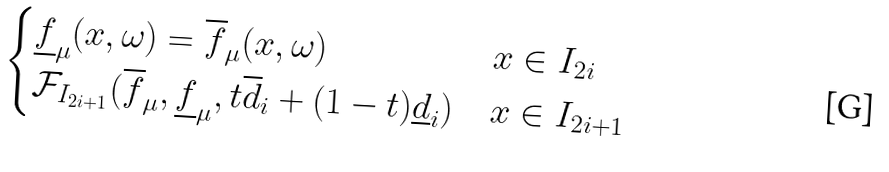<formula> <loc_0><loc_0><loc_500><loc_500>\begin{cases} \underline { f } _ { \mu } ( x , \omega ) = \overline { f } _ { \mu } ( x , \omega ) & x \in I _ { 2 i } \\ \mathcal { F } _ { I _ { 2 i + 1 } } ( \overline { f } _ { \mu } , \underline { f } _ { \mu } , t \overline { d } _ { i } + ( 1 - t ) \underline { d } _ { i } ) & x \in I _ { 2 i + 1 } \\ \end{cases}</formula> 